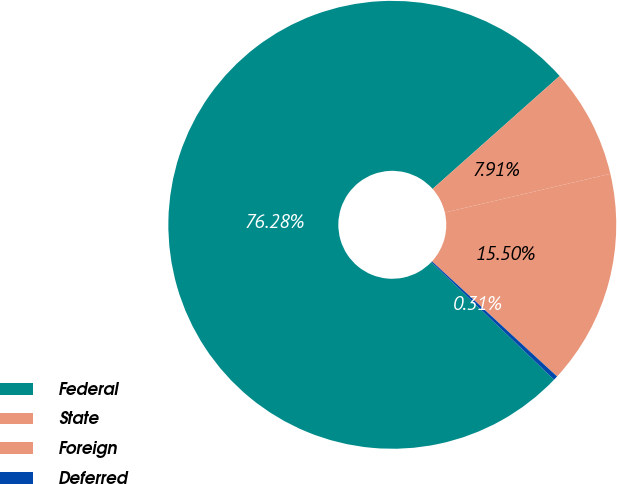Convert chart. <chart><loc_0><loc_0><loc_500><loc_500><pie_chart><fcel>Federal<fcel>State<fcel>Foreign<fcel>Deferred<nl><fcel>76.28%<fcel>7.91%<fcel>15.5%<fcel>0.31%<nl></chart> 